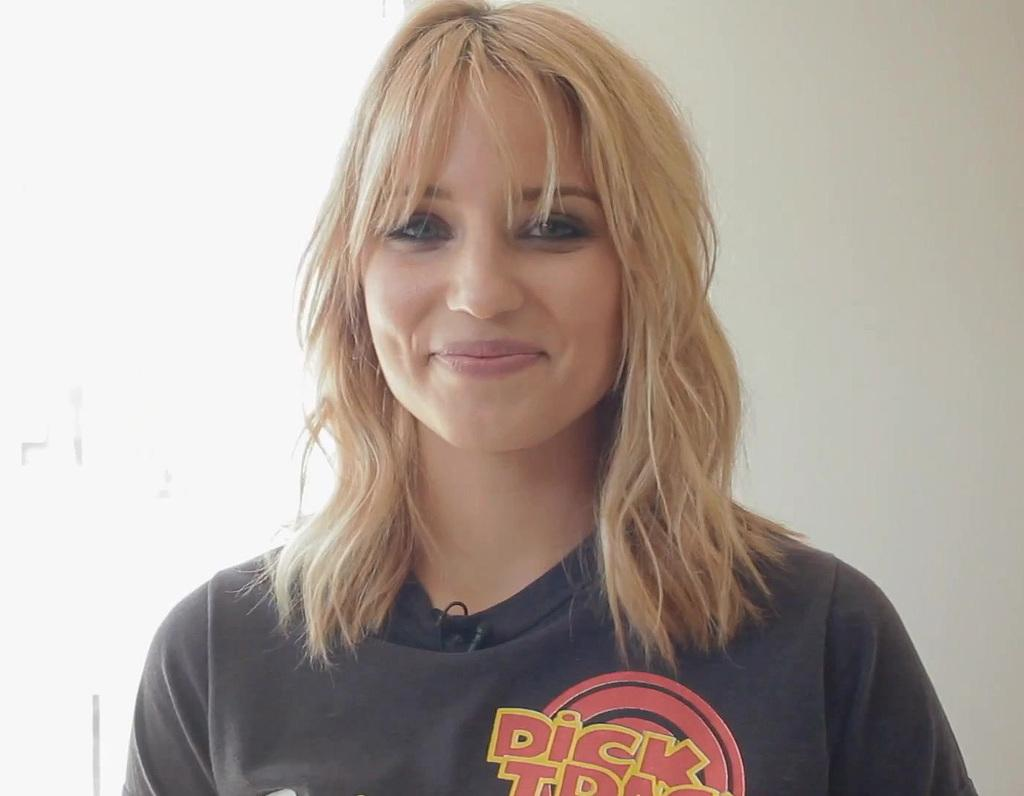<image>
Give a short and clear explanation of the subsequent image. a lady that is wearing a Dick Tracy shirt 